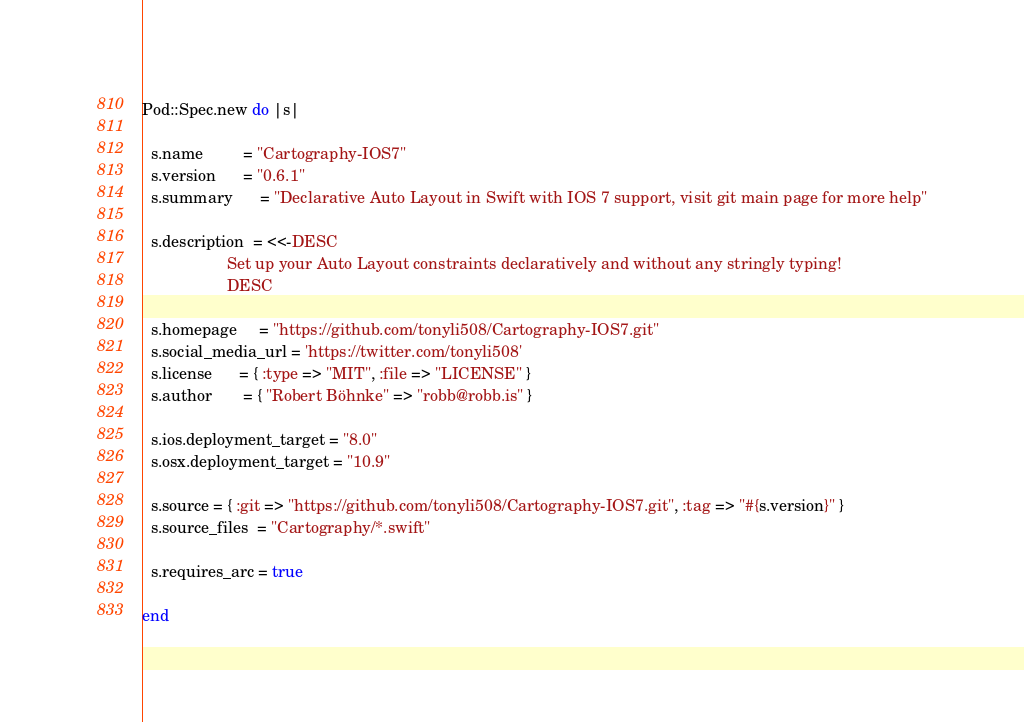Convert code to text. <code><loc_0><loc_0><loc_500><loc_500><_Ruby_>Pod::Spec.new do |s|

  s.name         = "Cartography-IOS7"
  s.version      = "0.6.1"
  s.summary      = "Declarative Auto Layout in Swift with IOS 7 support, visit git main page for more help"

  s.description  = <<-DESC
                   Set up your Auto Layout constraints declaratively and without any stringly typing!
                   DESC

  s.homepage     = "https://github.com/tonyli508/Cartography-IOS7.git"
  s.social_media_url = 'https://twitter.com/tonyli508'
  s.license      = { :type => "MIT", :file => "LICENSE" }
  s.author       = { "Robert Böhnke" => "robb@robb.is" }

  s.ios.deployment_target = "8.0"
  s.osx.deployment_target = "10.9"

  s.source = { :git => "https://github.com/tonyli508/Cartography-IOS7.git", :tag => "#{s.version}" }
  s.source_files  = "Cartography/*.swift"

  s.requires_arc = true

end
</code> 